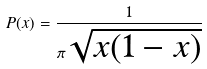Convert formula to latex. <formula><loc_0><loc_0><loc_500><loc_500>P ( x ) = \frac { 1 } { \pi \sqrt { x ( 1 - x ) } }</formula> 